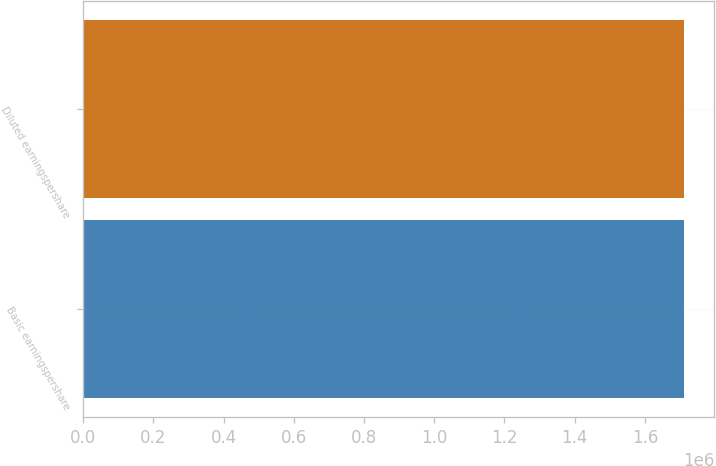Convert chart to OTSL. <chart><loc_0><loc_0><loc_500><loc_500><bar_chart><fcel>Basic earningspershare<fcel>Diluted earningspershare<nl><fcel>1.71256e+06<fcel>1.71256e+06<nl></chart> 